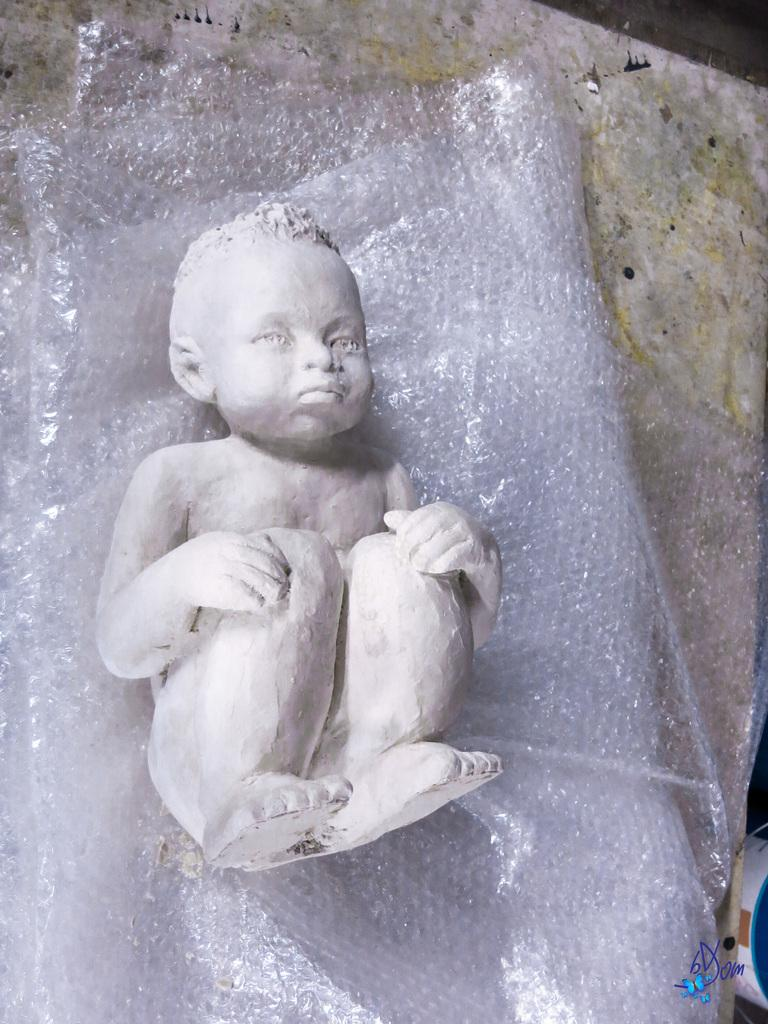What is the main subject of the image? There is a depiction of a baby in the image. What is the baby placed on? The baby is placed on a cover. What color is the surface beneath the cover? The surface beneath the cover is white. What can be seen beside the baby? There is an object beside the baby. How many daughters can be seen in the image? There are no daughters present in the image; it features a depiction of a baby. Was the image taken during an earthquake? There is no indication in the image that it was taken during an earthquake. 